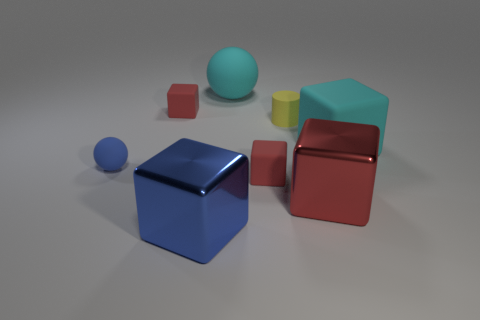What size is the other metal object that is the same shape as the large blue metallic thing?
Provide a short and direct response. Large. There is a red cube that is both on the left side of the tiny yellow thing and to the right of the big blue metal object; what size is it?
Your response must be concise. Small. Does the large matte ball have the same color as the large shiny cube that is on the left side of the yellow matte object?
Keep it short and to the point. No. How many blue things are cylinders or blocks?
Your answer should be very brief. 1. What is the shape of the big blue object?
Provide a short and direct response. Cube. How many other things are the same shape as the small blue object?
Make the answer very short. 1. There is a cube on the left side of the blue block; what is its color?
Provide a short and direct response. Red. Are the blue sphere and the large blue object made of the same material?
Give a very brief answer. No. How many objects are big red spheres or red objects that are in front of the tiny yellow cylinder?
Provide a succinct answer. 2. What is the size of the rubber block that is the same color as the large matte sphere?
Provide a succinct answer. Large. 